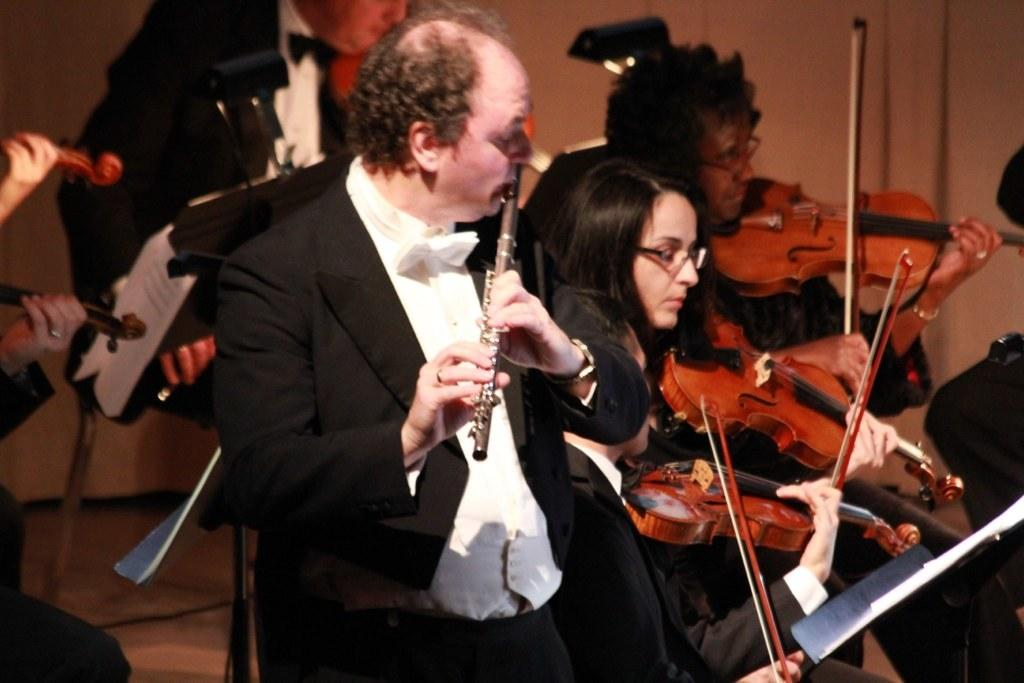Who is present in the image? There are people in the image. What are the people doing in the image? The people are playing musical instruments. Can you describe any additional objects or items the people are holding? Some people are holding a paper. Which direction are the people facing in the image? The provided facts do not specify the direction the people are facing in the image. --- Facts: 1. There is a person in the image. 2. The person is wearing a hat. 3. The person is holding a book. Absurd Topics: ocean Conversation: Who is present in the image? There is a person in the image. What is the person wearing in the image? The person is wearing a hat. What is the person holding in the image? The person is holding a book. Reasoning: Let's think step by step in order to produce the conversation. We start by identifying the main subject in the image, which is the person. Then, we describe specific features of the person, such as the hat. Next, we observe the actions of the person, noting that they are holding a book. Finally, we ensure that the language is simple and clear. Absurd Question/Answer: Can you see any ocean waves in the image? There is no reference to an ocean or waves in the provided facts. 